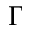Convert formula to latex. <formula><loc_0><loc_0><loc_500><loc_500>\Gamma</formula> 